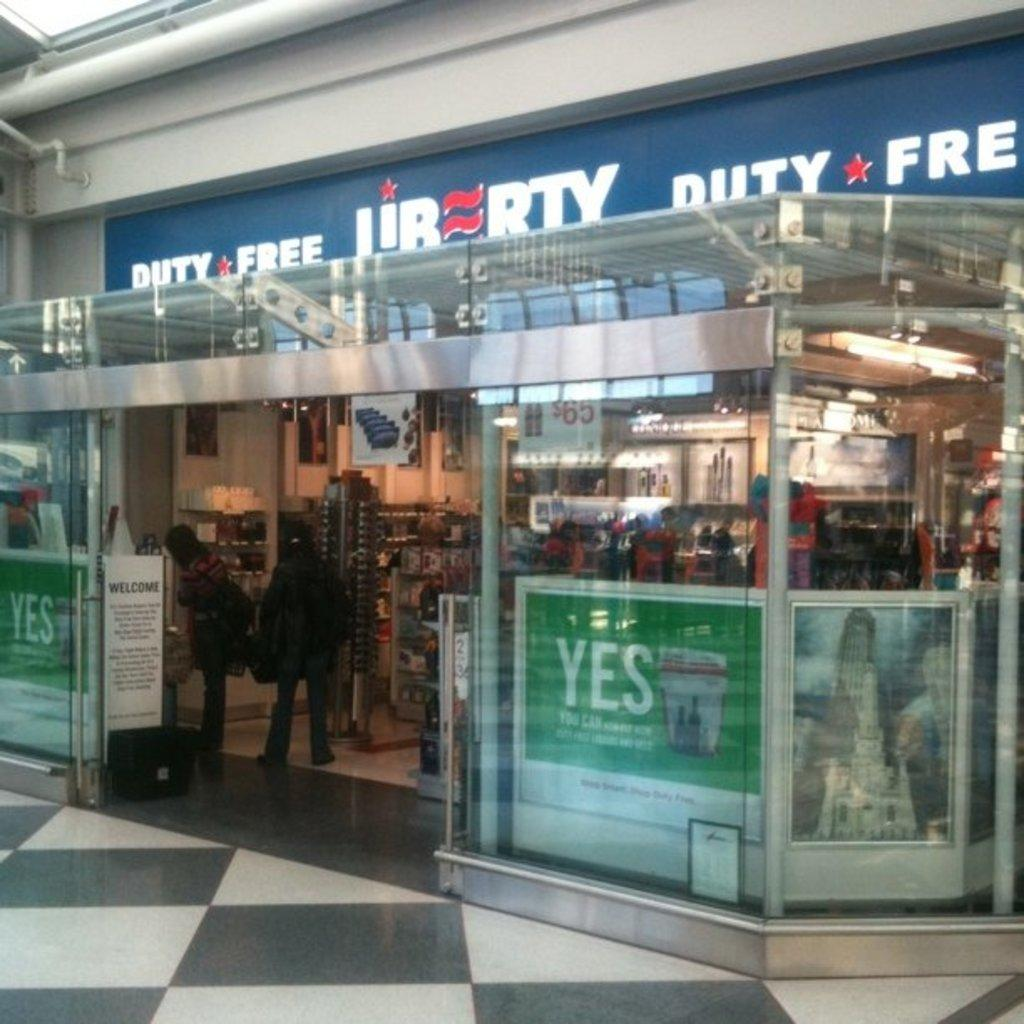<image>
Write a terse but informative summary of the picture. A shop called Liberty has duty free items. 